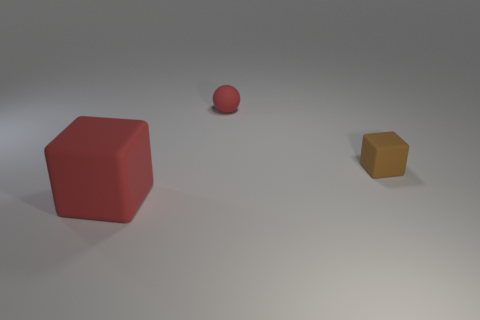Add 3 cyan shiny blocks. How many objects exist? 6 Subtract all spheres. How many objects are left? 2 Add 2 large rubber things. How many large rubber things are left? 3 Add 1 yellow matte blocks. How many yellow matte blocks exist? 1 Subtract 1 red balls. How many objects are left? 2 Subtract all cubes. Subtract all brown matte cubes. How many objects are left? 0 